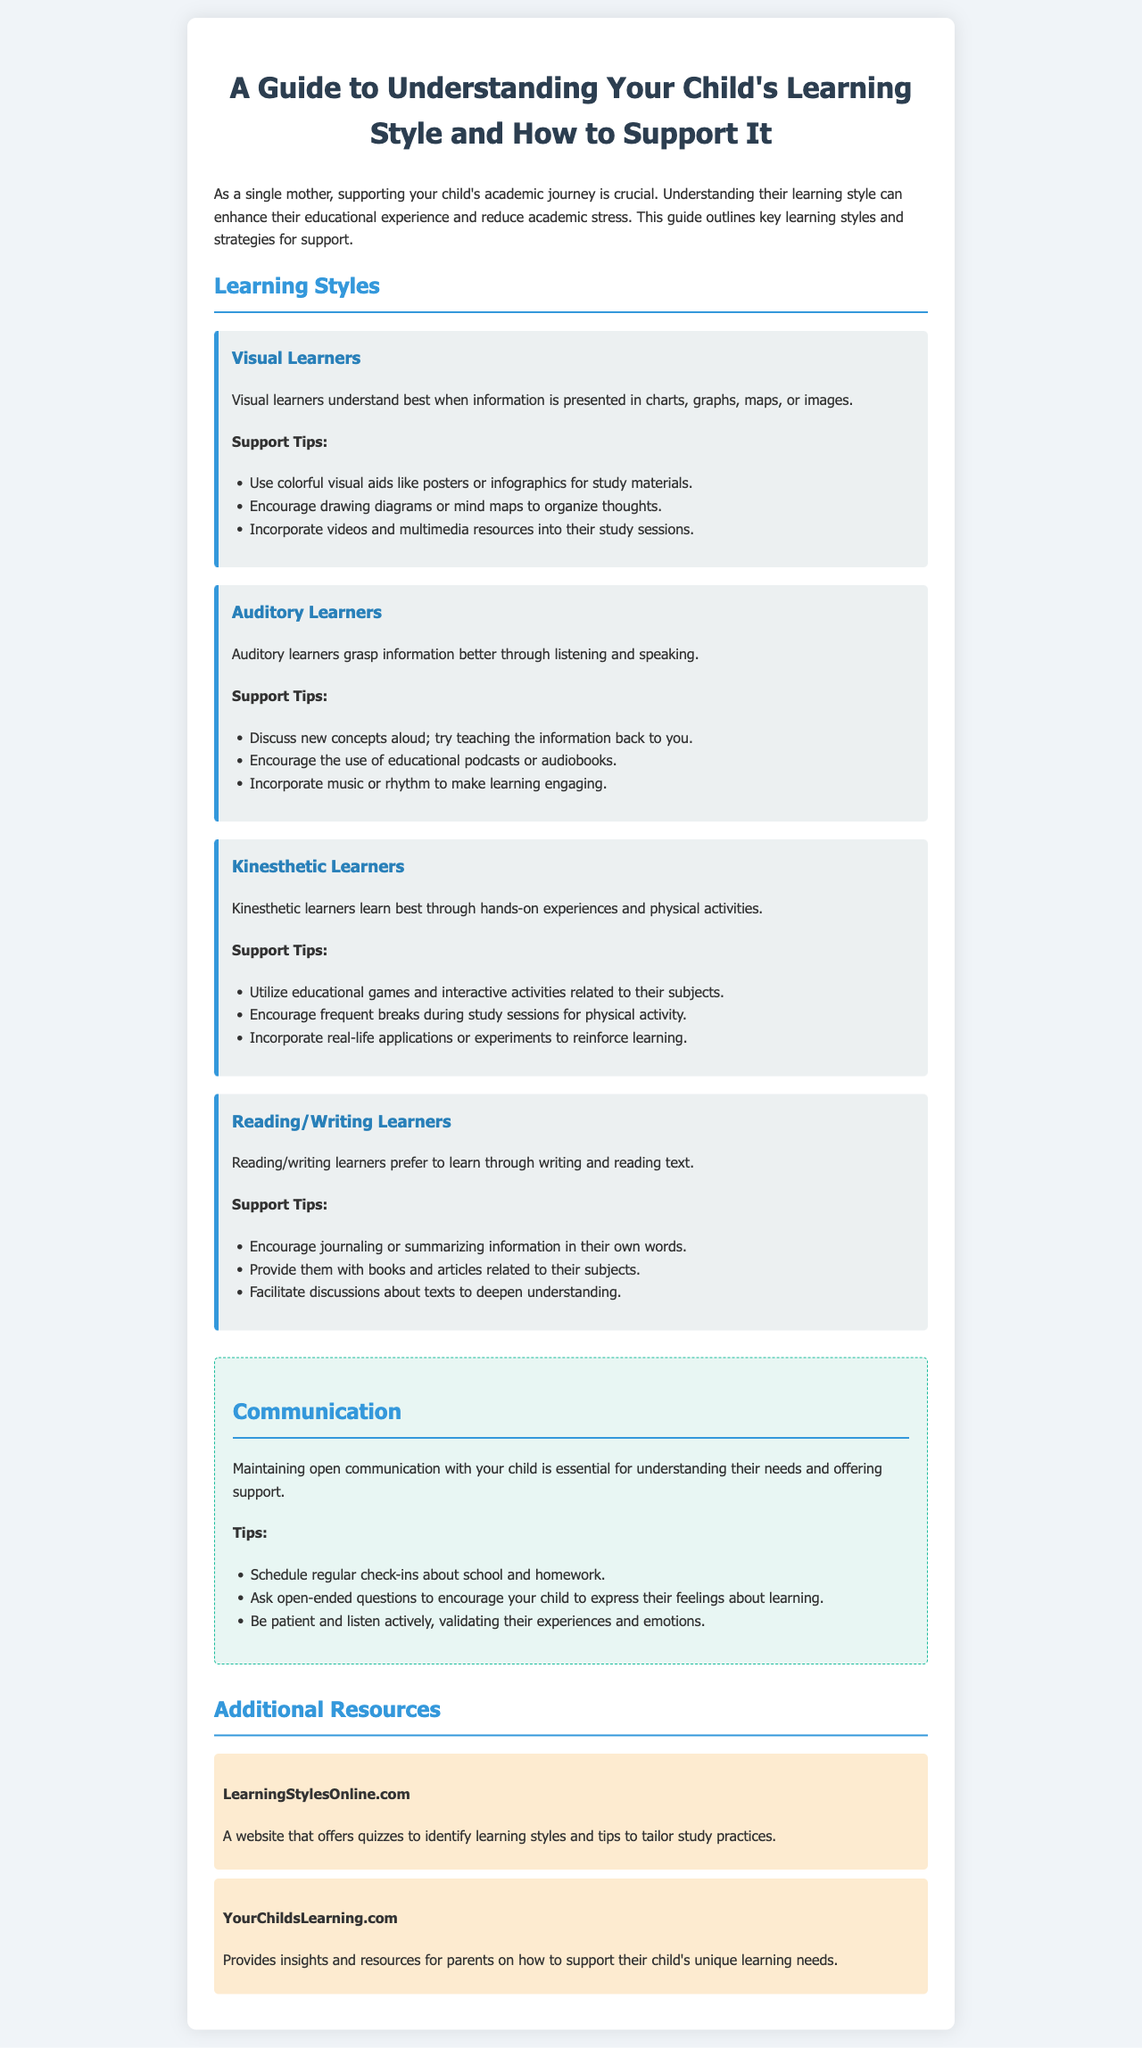What are the four learning styles mentioned? The document outlines four learning styles: Visual, Auditory, Kinesthetic, and Reading/Writing.
Answer: Visual, Auditory, Kinesthetic, Reading/Writing What type of learner prefers hands-on experiences? Kinesthetic learners learn best through hands-on experiences and physical activities.
Answer: Kinesthetic What is a recommended support tip for Visual Learners? The support tips for Visual Learners include using colorful visual aids like posters or infographics for study materials.
Answer: Use colorful visual aids How often should regular check-ins about school be scheduled? The document does not specify a frequency, but suggests maintaining regular communication about school and homework.
Answer: Regularly Which website offers quizzes to identify learning styles? LearningStylesOnline.com is mentioned as a resource providing quizzes to identify learning styles.
Answer: LearningStylesOnline.com What is one way to engage Auditory Learners when learning new concepts? Discussing new concepts aloud and encouraging them to explain the information back is a recommended strategy.
Answer: Discuss aloud What type of materials should Reading/Writing Learners be provided with? They should be provided with books and articles related to their subjects.
Answer: Books and articles How can a parent validate their child's experiences during communication? By listening actively and validating their experiences and emotions during conversations.
Answer: Listen actively What is a unique feature of the document? It includes both specific learning styles and support strategies for each type, making it tailored for helping children with academic stress.
Answer: Learning styles and support strategies 